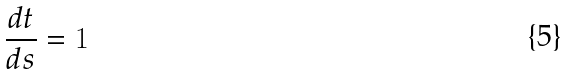<formula> <loc_0><loc_0><loc_500><loc_500>\frac { d t } { d s } = 1</formula> 